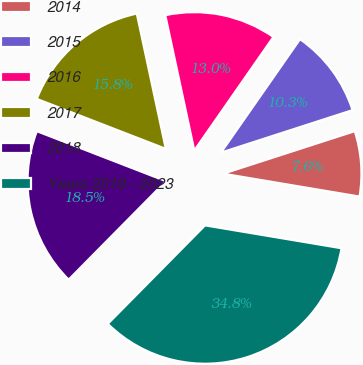<chart> <loc_0><loc_0><loc_500><loc_500><pie_chart><fcel>2014<fcel>2015<fcel>2016<fcel>2017<fcel>2018<fcel>Years 2019 - 2023<nl><fcel>7.62%<fcel>10.34%<fcel>13.05%<fcel>15.76%<fcel>18.48%<fcel>34.76%<nl></chart> 